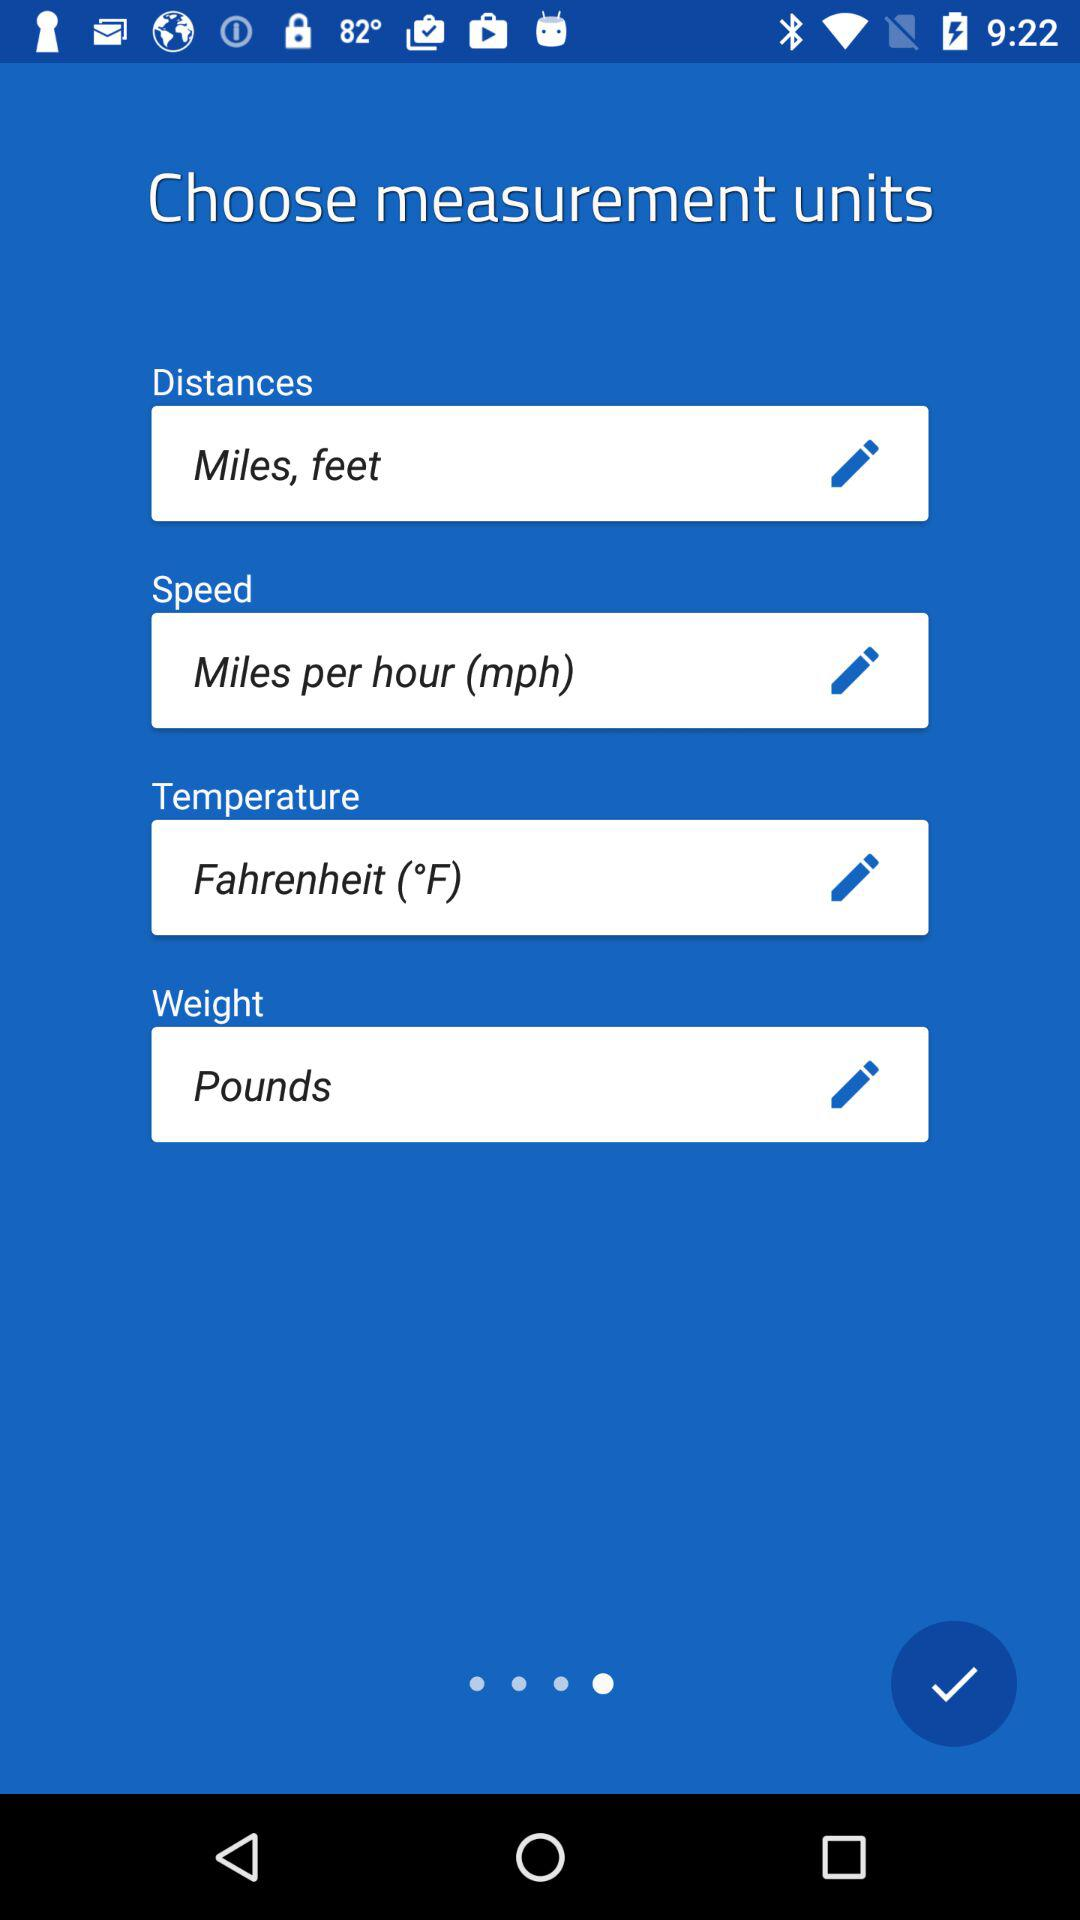How many input fields are there for selecting units?
Answer the question using a single word or phrase. 4 